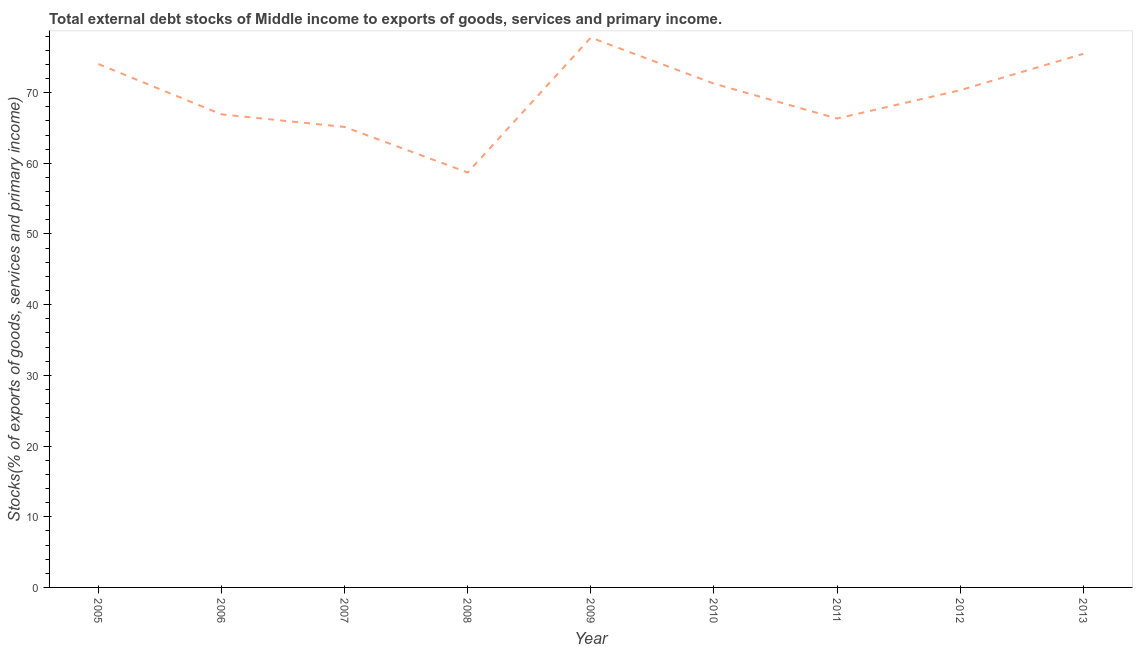What is the external debt stocks in 2006?
Give a very brief answer. 66.93. Across all years, what is the maximum external debt stocks?
Offer a terse response. 77.79. Across all years, what is the minimum external debt stocks?
Give a very brief answer. 58.7. In which year was the external debt stocks maximum?
Provide a short and direct response. 2009. In which year was the external debt stocks minimum?
Offer a very short reply. 2008. What is the sum of the external debt stocks?
Provide a short and direct response. 626.05. What is the difference between the external debt stocks in 2008 and 2010?
Your answer should be compact. -12.57. What is the average external debt stocks per year?
Offer a very short reply. 69.56. What is the median external debt stocks?
Your answer should be very brief. 70.34. What is the ratio of the external debt stocks in 2007 to that in 2011?
Your answer should be compact. 0.98. Is the difference between the external debt stocks in 2008 and 2011 greater than the difference between any two years?
Your response must be concise. No. What is the difference between the highest and the second highest external debt stocks?
Your answer should be very brief. 2.3. Is the sum of the external debt stocks in 2005 and 2007 greater than the maximum external debt stocks across all years?
Offer a terse response. Yes. What is the difference between the highest and the lowest external debt stocks?
Provide a short and direct response. 19.09. Does the external debt stocks monotonically increase over the years?
Provide a short and direct response. No. What is the difference between two consecutive major ticks on the Y-axis?
Your answer should be very brief. 10. What is the title of the graph?
Offer a terse response. Total external debt stocks of Middle income to exports of goods, services and primary income. What is the label or title of the Y-axis?
Offer a very short reply. Stocks(% of exports of goods, services and primary income). What is the Stocks(% of exports of goods, services and primary income) of 2005?
Provide a succinct answer. 74.05. What is the Stocks(% of exports of goods, services and primary income) in 2006?
Ensure brevity in your answer.  66.93. What is the Stocks(% of exports of goods, services and primary income) of 2007?
Your answer should be compact. 65.14. What is the Stocks(% of exports of goods, services and primary income) in 2008?
Offer a very short reply. 58.7. What is the Stocks(% of exports of goods, services and primary income) in 2009?
Offer a very short reply. 77.79. What is the Stocks(% of exports of goods, services and primary income) in 2010?
Your answer should be compact. 71.27. What is the Stocks(% of exports of goods, services and primary income) in 2011?
Your answer should be very brief. 66.34. What is the Stocks(% of exports of goods, services and primary income) in 2012?
Offer a terse response. 70.34. What is the Stocks(% of exports of goods, services and primary income) in 2013?
Your response must be concise. 75.49. What is the difference between the Stocks(% of exports of goods, services and primary income) in 2005 and 2006?
Give a very brief answer. 7.12. What is the difference between the Stocks(% of exports of goods, services and primary income) in 2005 and 2007?
Provide a short and direct response. 8.9. What is the difference between the Stocks(% of exports of goods, services and primary income) in 2005 and 2008?
Ensure brevity in your answer.  15.35. What is the difference between the Stocks(% of exports of goods, services and primary income) in 2005 and 2009?
Offer a very short reply. -3.74. What is the difference between the Stocks(% of exports of goods, services and primary income) in 2005 and 2010?
Keep it short and to the point. 2.77. What is the difference between the Stocks(% of exports of goods, services and primary income) in 2005 and 2011?
Your answer should be very brief. 7.71. What is the difference between the Stocks(% of exports of goods, services and primary income) in 2005 and 2012?
Make the answer very short. 3.71. What is the difference between the Stocks(% of exports of goods, services and primary income) in 2005 and 2013?
Give a very brief answer. -1.44. What is the difference between the Stocks(% of exports of goods, services and primary income) in 2006 and 2007?
Your response must be concise. 1.78. What is the difference between the Stocks(% of exports of goods, services and primary income) in 2006 and 2008?
Your response must be concise. 8.23. What is the difference between the Stocks(% of exports of goods, services and primary income) in 2006 and 2009?
Give a very brief answer. -10.86. What is the difference between the Stocks(% of exports of goods, services and primary income) in 2006 and 2010?
Provide a succinct answer. -4.34. What is the difference between the Stocks(% of exports of goods, services and primary income) in 2006 and 2011?
Provide a short and direct response. 0.59. What is the difference between the Stocks(% of exports of goods, services and primary income) in 2006 and 2012?
Offer a very short reply. -3.41. What is the difference between the Stocks(% of exports of goods, services and primary income) in 2006 and 2013?
Give a very brief answer. -8.56. What is the difference between the Stocks(% of exports of goods, services and primary income) in 2007 and 2008?
Offer a terse response. 6.44. What is the difference between the Stocks(% of exports of goods, services and primary income) in 2007 and 2009?
Give a very brief answer. -12.64. What is the difference between the Stocks(% of exports of goods, services and primary income) in 2007 and 2010?
Ensure brevity in your answer.  -6.13. What is the difference between the Stocks(% of exports of goods, services and primary income) in 2007 and 2011?
Keep it short and to the point. -1.19. What is the difference between the Stocks(% of exports of goods, services and primary income) in 2007 and 2012?
Your answer should be very brief. -5.2. What is the difference between the Stocks(% of exports of goods, services and primary income) in 2007 and 2013?
Ensure brevity in your answer.  -10.35. What is the difference between the Stocks(% of exports of goods, services and primary income) in 2008 and 2009?
Give a very brief answer. -19.09. What is the difference between the Stocks(% of exports of goods, services and primary income) in 2008 and 2010?
Ensure brevity in your answer.  -12.57. What is the difference between the Stocks(% of exports of goods, services and primary income) in 2008 and 2011?
Your response must be concise. -7.64. What is the difference between the Stocks(% of exports of goods, services and primary income) in 2008 and 2012?
Provide a short and direct response. -11.64. What is the difference between the Stocks(% of exports of goods, services and primary income) in 2008 and 2013?
Keep it short and to the point. -16.79. What is the difference between the Stocks(% of exports of goods, services and primary income) in 2009 and 2010?
Ensure brevity in your answer.  6.52. What is the difference between the Stocks(% of exports of goods, services and primary income) in 2009 and 2011?
Offer a terse response. 11.45. What is the difference between the Stocks(% of exports of goods, services and primary income) in 2009 and 2012?
Offer a terse response. 7.45. What is the difference between the Stocks(% of exports of goods, services and primary income) in 2009 and 2013?
Your answer should be very brief. 2.3. What is the difference between the Stocks(% of exports of goods, services and primary income) in 2010 and 2011?
Your response must be concise. 4.94. What is the difference between the Stocks(% of exports of goods, services and primary income) in 2010 and 2012?
Your answer should be compact. 0.93. What is the difference between the Stocks(% of exports of goods, services and primary income) in 2010 and 2013?
Your answer should be very brief. -4.22. What is the difference between the Stocks(% of exports of goods, services and primary income) in 2011 and 2012?
Keep it short and to the point. -4. What is the difference between the Stocks(% of exports of goods, services and primary income) in 2011 and 2013?
Offer a very short reply. -9.15. What is the difference between the Stocks(% of exports of goods, services and primary income) in 2012 and 2013?
Ensure brevity in your answer.  -5.15. What is the ratio of the Stocks(% of exports of goods, services and primary income) in 2005 to that in 2006?
Your answer should be very brief. 1.11. What is the ratio of the Stocks(% of exports of goods, services and primary income) in 2005 to that in 2007?
Ensure brevity in your answer.  1.14. What is the ratio of the Stocks(% of exports of goods, services and primary income) in 2005 to that in 2008?
Your answer should be compact. 1.26. What is the ratio of the Stocks(% of exports of goods, services and primary income) in 2005 to that in 2009?
Your answer should be compact. 0.95. What is the ratio of the Stocks(% of exports of goods, services and primary income) in 2005 to that in 2010?
Provide a succinct answer. 1.04. What is the ratio of the Stocks(% of exports of goods, services and primary income) in 2005 to that in 2011?
Offer a terse response. 1.12. What is the ratio of the Stocks(% of exports of goods, services and primary income) in 2005 to that in 2012?
Make the answer very short. 1.05. What is the ratio of the Stocks(% of exports of goods, services and primary income) in 2006 to that in 2008?
Your answer should be compact. 1.14. What is the ratio of the Stocks(% of exports of goods, services and primary income) in 2006 to that in 2009?
Offer a terse response. 0.86. What is the ratio of the Stocks(% of exports of goods, services and primary income) in 2006 to that in 2010?
Ensure brevity in your answer.  0.94. What is the ratio of the Stocks(% of exports of goods, services and primary income) in 2006 to that in 2012?
Provide a short and direct response. 0.95. What is the ratio of the Stocks(% of exports of goods, services and primary income) in 2006 to that in 2013?
Provide a short and direct response. 0.89. What is the ratio of the Stocks(% of exports of goods, services and primary income) in 2007 to that in 2008?
Provide a short and direct response. 1.11. What is the ratio of the Stocks(% of exports of goods, services and primary income) in 2007 to that in 2009?
Offer a very short reply. 0.84. What is the ratio of the Stocks(% of exports of goods, services and primary income) in 2007 to that in 2010?
Offer a very short reply. 0.91. What is the ratio of the Stocks(% of exports of goods, services and primary income) in 2007 to that in 2011?
Give a very brief answer. 0.98. What is the ratio of the Stocks(% of exports of goods, services and primary income) in 2007 to that in 2012?
Offer a terse response. 0.93. What is the ratio of the Stocks(% of exports of goods, services and primary income) in 2007 to that in 2013?
Offer a very short reply. 0.86. What is the ratio of the Stocks(% of exports of goods, services and primary income) in 2008 to that in 2009?
Give a very brief answer. 0.76. What is the ratio of the Stocks(% of exports of goods, services and primary income) in 2008 to that in 2010?
Make the answer very short. 0.82. What is the ratio of the Stocks(% of exports of goods, services and primary income) in 2008 to that in 2011?
Give a very brief answer. 0.89. What is the ratio of the Stocks(% of exports of goods, services and primary income) in 2008 to that in 2012?
Provide a short and direct response. 0.83. What is the ratio of the Stocks(% of exports of goods, services and primary income) in 2008 to that in 2013?
Offer a very short reply. 0.78. What is the ratio of the Stocks(% of exports of goods, services and primary income) in 2009 to that in 2010?
Make the answer very short. 1.09. What is the ratio of the Stocks(% of exports of goods, services and primary income) in 2009 to that in 2011?
Give a very brief answer. 1.17. What is the ratio of the Stocks(% of exports of goods, services and primary income) in 2009 to that in 2012?
Keep it short and to the point. 1.11. What is the ratio of the Stocks(% of exports of goods, services and primary income) in 2010 to that in 2011?
Ensure brevity in your answer.  1.07. What is the ratio of the Stocks(% of exports of goods, services and primary income) in 2010 to that in 2013?
Offer a terse response. 0.94. What is the ratio of the Stocks(% of exports of goods, services and primary income) in 2011 to that in 2012?
Your answer should be very brief. 0.94. What is the ratio of the Stocks(% of exports of goods, services and primary income) in 2011 to that in 2013?
Keep it short and to the point. 0.88. What is the ratio of the Stocks(% of exports of goods, services and primary income) in 2012 to that in 2013?
Your response must be concise. 0.93. 